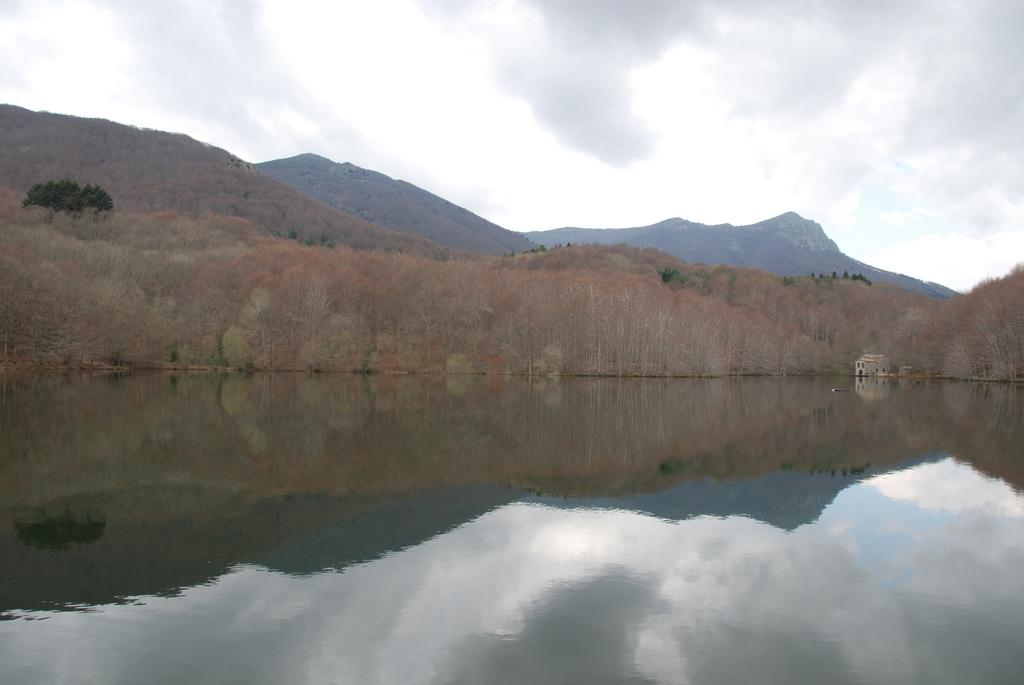What natural element is visible in the image? Water is visible in the image. What type of vegetation can be seen in the image? There are trees in the image. What geographical feature is present in the image? There are hills in the image. What type of structure is present in the image? There is a building in the image. What is visible in the sky in the image? The sky is visible in the image, along with clouds. Which direction does the light come from in the image? There is no mention of light or its direction in the image. Can you tell me how many times the trees turn in the image? Trees do not turn in the image; they are stationary. 